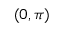Convert formula to latex. <formula><loc_0><loc_0><loc_500><loc_500>( 0 , \pi )</formula> 